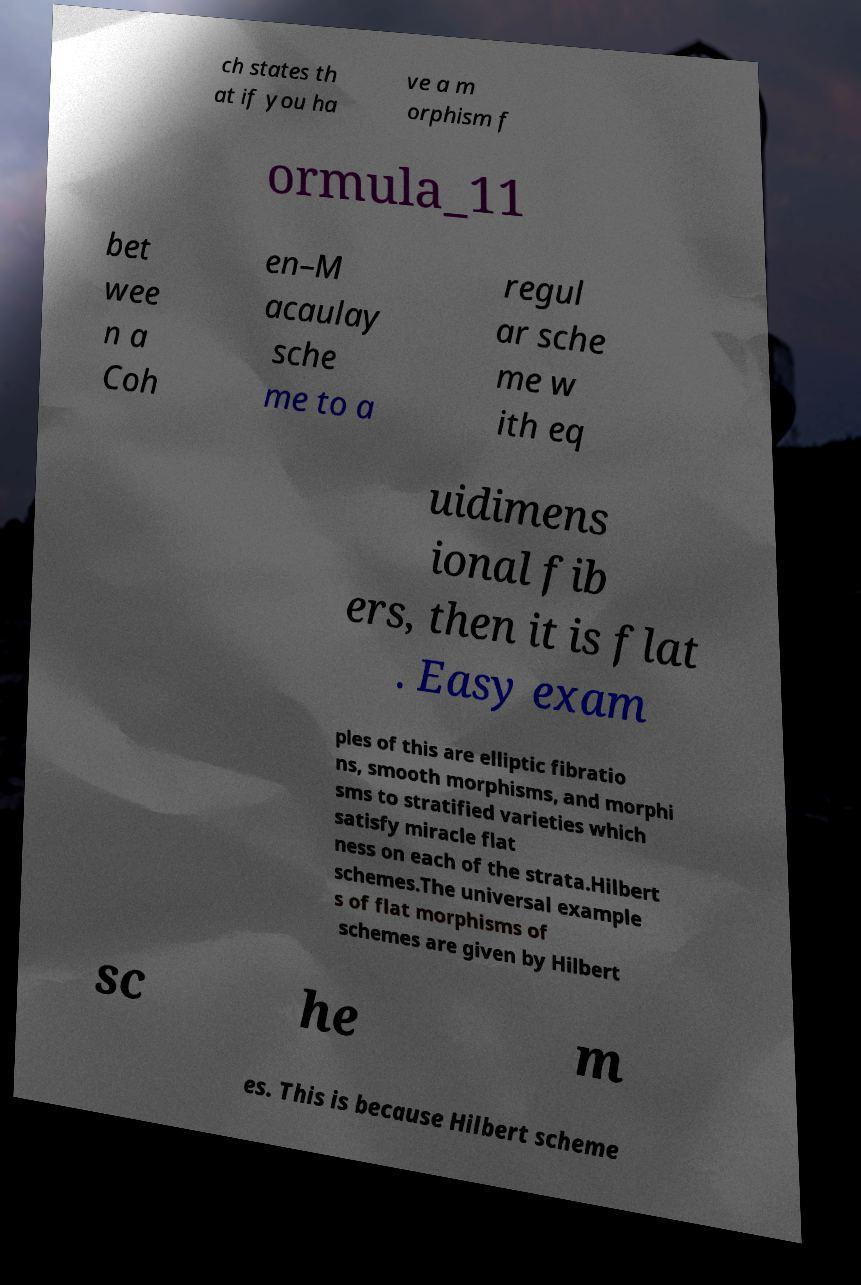Could you extract and type out the text from this image? ch states th at if you ha ve a m orphism f ormula_11 bet wee n a Coh en–M acaulay sche me to a regul ar sche me w ith eq uidimens ional fib ers, then it is flat . Easy exam ples of this are elliptic fibratio ns, smooth morphisms, and morphi sms to stratified varieties which satisfy miracle flat ness on each of the strata.Hilbert schemes.The universal example s of flat morphisms of schemes are given by Hilbert sc he m es. This is because Hilbert scheme 